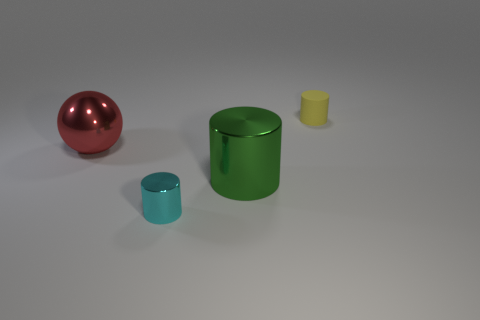Add 1 tiny green metal spheres. How many objects exist? 5 Subtract all spheres. How many objects are left? 3 Add 2 small matte cylinders. How many small matte cylinders are left? 3 Add 1 small objects. How many small objects exist? 3 Subtract 0 yellow spheres. How many objects are left? 4 Subtract all tiny cyan objects. Subtract all yellow balls. How many objects are left? 3 